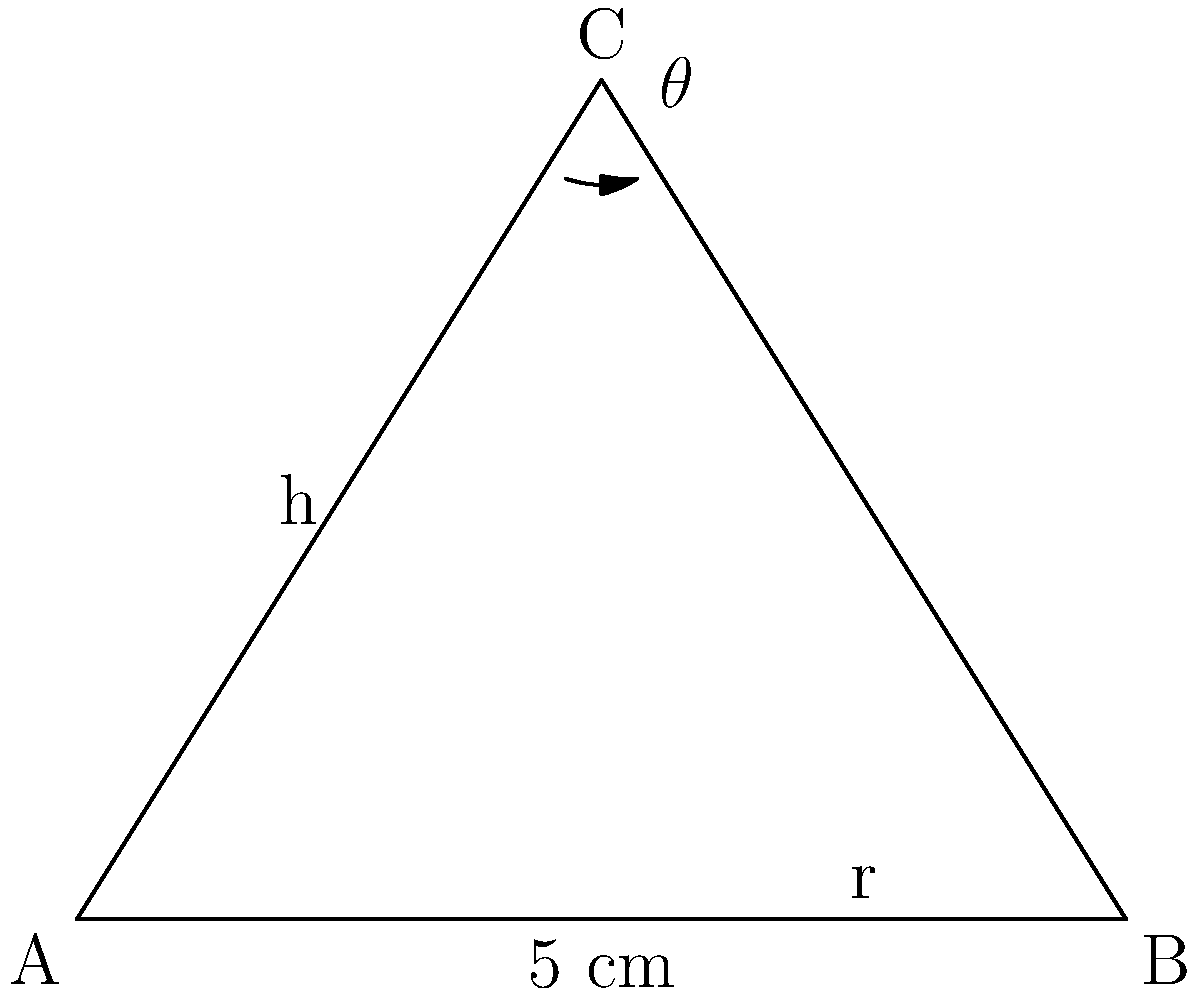As a graduate student in synthetic chemistry, you're designing a conical reaction vessel. The vessel has a base radius of 2.5 cm and a slant height of 5 cm. Determine the optimal angle $\theta$ (in degrees) between the side and base of the cone that maximizes the ratio of volume to surface area. Round your answer to the nearest degree. Let's approach this step-by-step:

1) First, we need to express the volume (V) and surface area (SA) in terms of $\theta$:

   $V = \frac{1}{3}\pi r^2 h$
   $SA = \pi r^2 + \pi r s$

   Where $r$ is the radius, $h$ is the height, and $s$ is the slant height.

2) We know $s = 5$ cm and $r = 2.5$ cm. We need to express $h$ in terms of $\theta$:

   $\tan \theta = \frac{h}{r} = \frac{h}{2.5}$
   $h = 2.5 \tan \theta$

3) Now we can express V and SA in terms of $\theta$:

   $V = \frac{1}{3}\pi (2.5)^2 (2.5 \tan \theta) = \frac{13.0208}{3} \tan \theta$

   $SA = \pi (2.5)^2 + \pi (2.5)(5) = 19.6349 + 39.2699 = 58.9048$

4) The ratio we want to maximize is:

   $\frac{V}{SA} = \frac{4.3403 \tan \theta}{58.9048} = 0.0737 \tan \theta$

5) To find the maximum, we need to differentiate this with respect to $\theta$ and set it to zero:

   $\frac{d}{d\theta}(0.0737 \tan \theta) = 0.0737 \sec^2 \theta = 0$

6) This equation is never zero for real $\theta$, which means the maximum occurs at the boundary of our domain. The maximum possible $\theta$ is when the height equals the radius:

   $\tan \theta = \frac{h}{r} = 1$

7) Therefore, the optimal angle is:

   $\theta = \arctan(1) = 45°$
Answer: 45° 